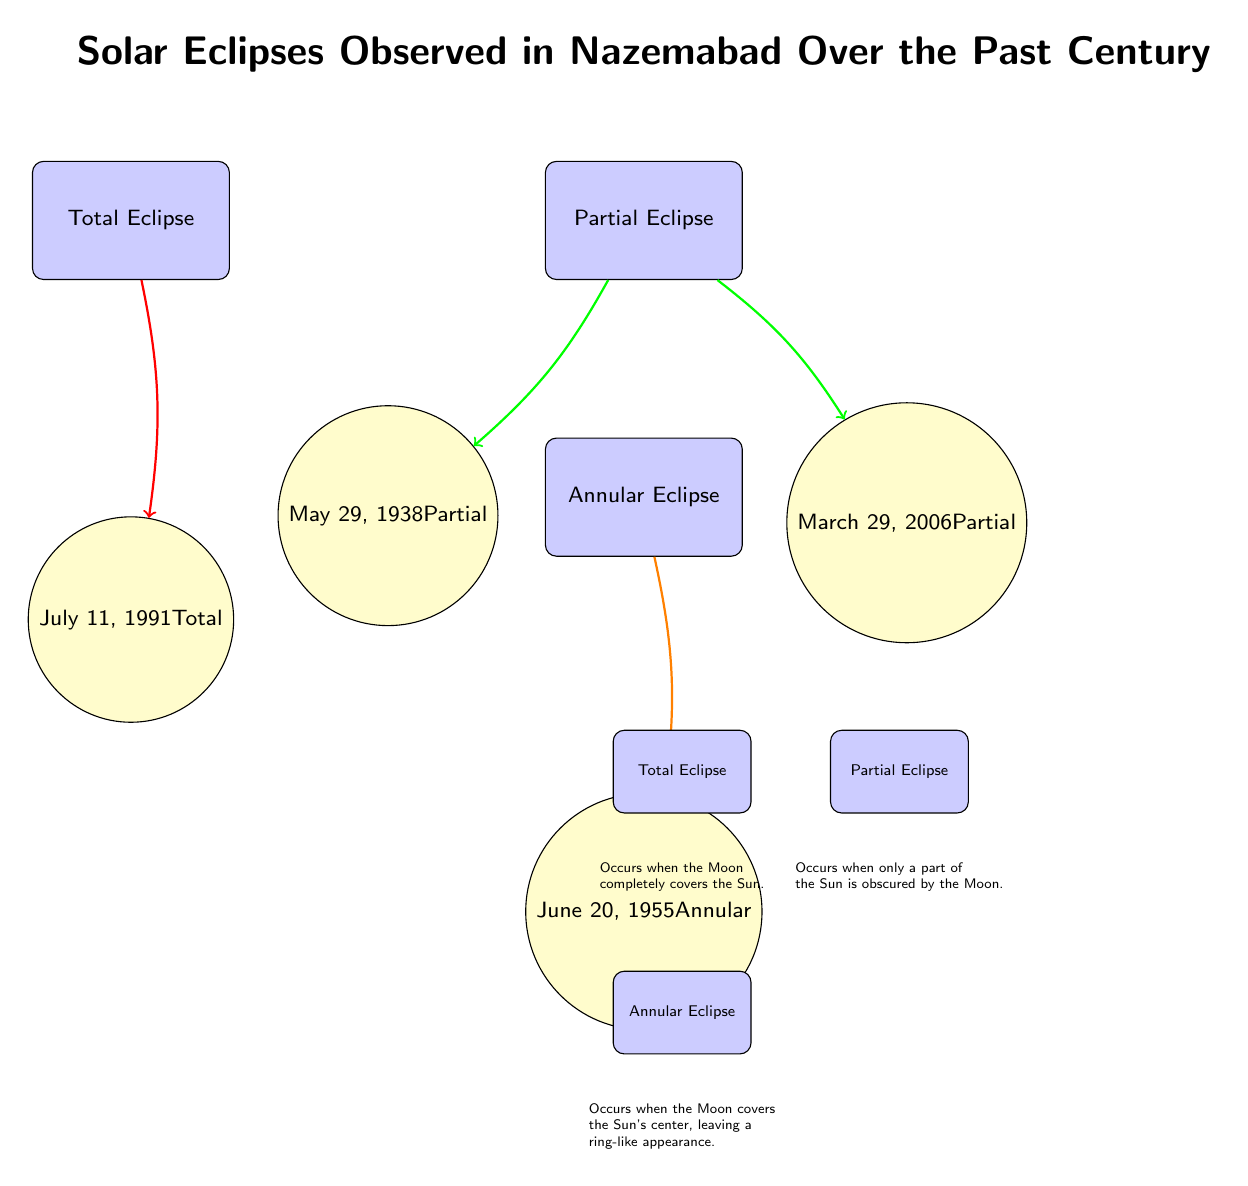What types of eclipses are represented in the diagram? The diagram includes three types of eclipses: Total Eclipse, Partial Eclipse, and Annular Eclipse. These are directly labeled as nodes in the diagram.
Answer: Total Eclipse, Partial Eclipse, Annular Eclipse How many total eclipses are recorded in the diagram? The diagram indicates there is one total eclipse, which is the July 11, 1991 event, labeled directly under the Total Eclipse node.
Answer: 1 What is the date of the partial eclipse that occurred on May 29, 1938? The date is labeled directly next to the Partial Eclipse node connected to the May 29, 1938 event, allowing a straightforward retrieval of this information.
Answer: May 29, 1938 Which type of eclipse occurs when only a part of the Sun is obscured by the Moon? The diagram explains this phenomenon under the legend for Partial Eclipse, where it states that this type occurs when only part of the Sun is obscured.
Answer: Partial Eclipse Is there a connection from "Total Eclipse" to any events in the diagram? Yes, the diagram shows a direct arrow from the Total Eclipse type node to the July 11, 1991 event, indicating that this event is a total eclipse.
Answer: Yes How many partial eclipse events are shown in the diagram? There are two partial eclipse events listed: May 29, 1938, and March 29, 2006, which are both connected to the Partial Eclipse node, allowing for an easy count.
Answer: 2 What is the first recorded eclipse shown in the diagram? The diagram lists the eclipses chronologically, and May 29, 1938 is the first date represented, as it appears at the top under the Partial Eclipse category.
Answer: May 29, 1938 What color represents the Annular Eclipse in the diagram? The annular eclipse node is filled with orange, which is utilized to represent this type of eclipse in the diagram's node characteristics.
Answer: Orange How would you describe the appearance of an Annular Eclipse based on the legend? The legend specifies that an Annular Eclipse occurs when the Moon covers the Sun's center, leaving a ring-like appearance, summarizing how this phenomenon looks visually.
Answer: Ring-like appearance 